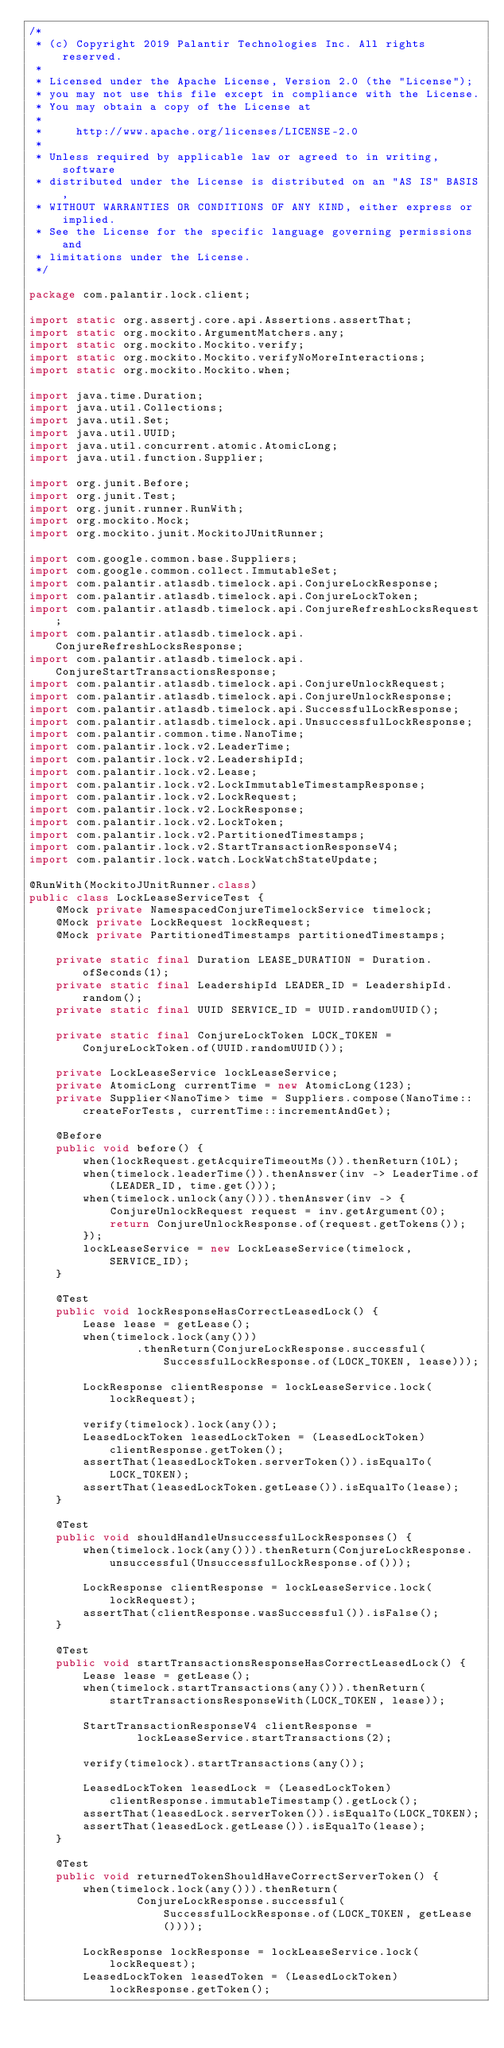Convert code to text. <code><loc_0><loc_0><loc_500><loc_500><_Java_>/*
 * (c) Copyright 2019 Palantir Technologies Inc. All rights reserved.
 *
 * Licensed under the Apache License, Version 2.0 (the "License");
 * you may not use this file except in compliance with the License.
 * You may obtain a copy of the License at
 *
 *     http://www.apache.org/licenses/LICENSE-2.0
 *
 * Unless required by applicable law or agreed to in writing, software
 * distributed under the License is distributed on an "AS IS" BASIS,
 * WITHOUT WARRANTIES OR CONDITIONS OF ANY KIND, either express or implied.
 * See the License for the specific language governing permissions and
 * limitations under the License.
 */

package com.palantir.lock.client;

import static org.assertj.core.api.Assertions.assertThat;
import static org.mockito.ArgumentMatchers.any;
import static org.mockito.Mockito.verify;
import static org.mockito.Mockito.verifyNoMoreInteractions;
import static org.mockito.Mockito.when;

import java.time.Duration;
import java.util.Collections;
import java.util.Set;
import java.util.UUID;
import java.util.concurrent.atomic.AtomicLong;
import java.util.function.Supplier;

import org.junit.Before;
import org.junit.Test;
import org.junit.runner.RunWith;
import org.mockito.Mock;
import org.mockito.junit.MockitoJUnitRunner;

import com.google.common.base.Suppliers;
import com.google.common.collect.ImmutableSet;
import com.palantir.atlasdb.timelock.api.ConjureLockResponse;
import com.palantir.atlasdb.timelock.api.ConjureLockToken;
import com.palantir.atlasdb.timelock.api.ConjureRefreshLocksRequest;
import com.palantir.atlasdb.timelock.api.ConjureRefreshLocksResponse;
import com.palantir.atlasdb.timelock.api.ConjureStartTransactionsResponse;
import com.palantir.atlasdb.timelock.api.ConjureUnlockRequest;
import com.palantir.atlasdb.timelock.api.ConjureUnlockResponse;
import com.palantir.atlasdb.timelock.api.SuccessfulLockResponse;
import com.palantir.atlasdb.timelock.api.UnsuccessfulLockResponse;
import com.palantir.common.time.NanoTime;
import com.palantir.lock.v2.LeaderTime;
import com.palantir.lock.v2.LeadershipId;
import com.palantir.lock.v2.Lease;
import com.palantir.lock.v2.LockImmutableTimestampResponse;
import com.palantir.lock.v2.LockRequest;
import com.palantir.lock.v2.LockResponse;
import com.palantir.lock.v2.LockToken;
import com.palantir.lock.v2.PartitionedTimestamps;
import com.palantir.lock.v2.StartTransactionResponseV4;
import com.palantir.lock.watch.LockWatchStateUpdate;

@RunWith(MockitoJUnitRunner.class)
public class LockLeaseServiceTest {
    @Mock private NamespacedConjureTimelockService timelock;
    @Mock private LockRequest lockRequest;
    @Mock private PartitionedTimestamps partitionedTimestamps;

    private static final Duration LEASE_DURATION = Duration.ofSeconds(1);
    private static final LeadershipId LEADER_ID = LeadershipId.random();
    private static final UUID SERVICE_ID = UUID.randomUUID();

    private static final ConjureLockToken LOCK_TOKEN = ConjureLockToken.of(UUID.randomUUID());

    private LockLeaseService lockLeaseService;
    private AtomicLong currentTime = new AtomicLong(123);
    private Supplier<NanoTime> time = Suppliers.compose(NanoTime::createForTests, currentTime::incrementAndGet);

    @Before
    public void before() {
        when(lockRequest.getAcquireTimeoutMs()).thenReturn(10L);
        when(timelock.leaderTime()).thenAnswer(inv -> LeaderTime.of(LEADER_ID, time.get()));
        when(timelock.unlock(any())).thenAnswer(inv -> {
            ConjureUnlockRequest request = inv.getArgument(0);
            return ConjureUnlockResponse.of(request.getTokens());
        });
        lockLeaseService = new LockLeaseService(timelock, SERVICE_ID);
    }

    @Test
    public void lockResponseHasCorrectLeasedLock() {
        Lease lease = getLease();
        when(timelock.lock(any()))
                .thenReturn(ConjureLockResponse.successful(SuccessfulLockResponse.of(LOCK_TOKEN, lease)));

        LockResponse clientResponse = lockLeaseService.lock(lockRequest);

        verify(timelock).lock(any());
        LeasedLockToken leasedLockToken = (LeasedLockToken) clientResponse.getToken();
        assertThat(leasedLockToken.serverToken()).isEqualTo(LOCK_TOKEN);
        assertThat(leasedLockToken.getLease()).isEqualTo(lease);
    }

    @Test
    public void shouldHandleUnsuccessfulLockResponses() {
        when(timelock.lock(any())).thenReturn(ConjureLockResponse.unsuccessful(UnsuccessfulLockResponse.of()));

        LockResponse clientResponse = lockLeaseService.lock(lockRequest);
        assertThat(clientResponse.wasSuccessful()).isFalse();
    }

    @Test
    public void startTransactionsResponseHasCorrectLeasedLock() {
        Lease lease = getLease();
        when(timelock.startTransactions(any())).thenReturn(startTransactionsResponseWith(LOCK_TOKEN, lease));

        StartTransactionResponseV4 clientResponse =
                lockLeaseService.startTransactions(2);

        verify(timelock).startTransactions(any());

        LeasedLockToken leasedLock = (LeasedLockToken) clientResponse.immutableTimestamp().getLock();
        assertThat(leasedLock.serverToken()).isEqualTo(LOCK_TOKEN);
        assertThat(leasedLock.getLease()).isEqualTo(lease);
    }

    @Test
    public void returnedTokenShouldHaveCorrectServerToken() {
        when(timelock.lock(any())).thenReturn(
                ConjureLockResponse.successful(SuccessfulLockResponse.of(LOCK_TOKEN, getLease())));

        LockResponse lockResponse = lockLeaseService.lock(lockRequest);
        LeasedLockToken leasedToken = (LeasedLockToken) lockResponse.getToken();</code> 